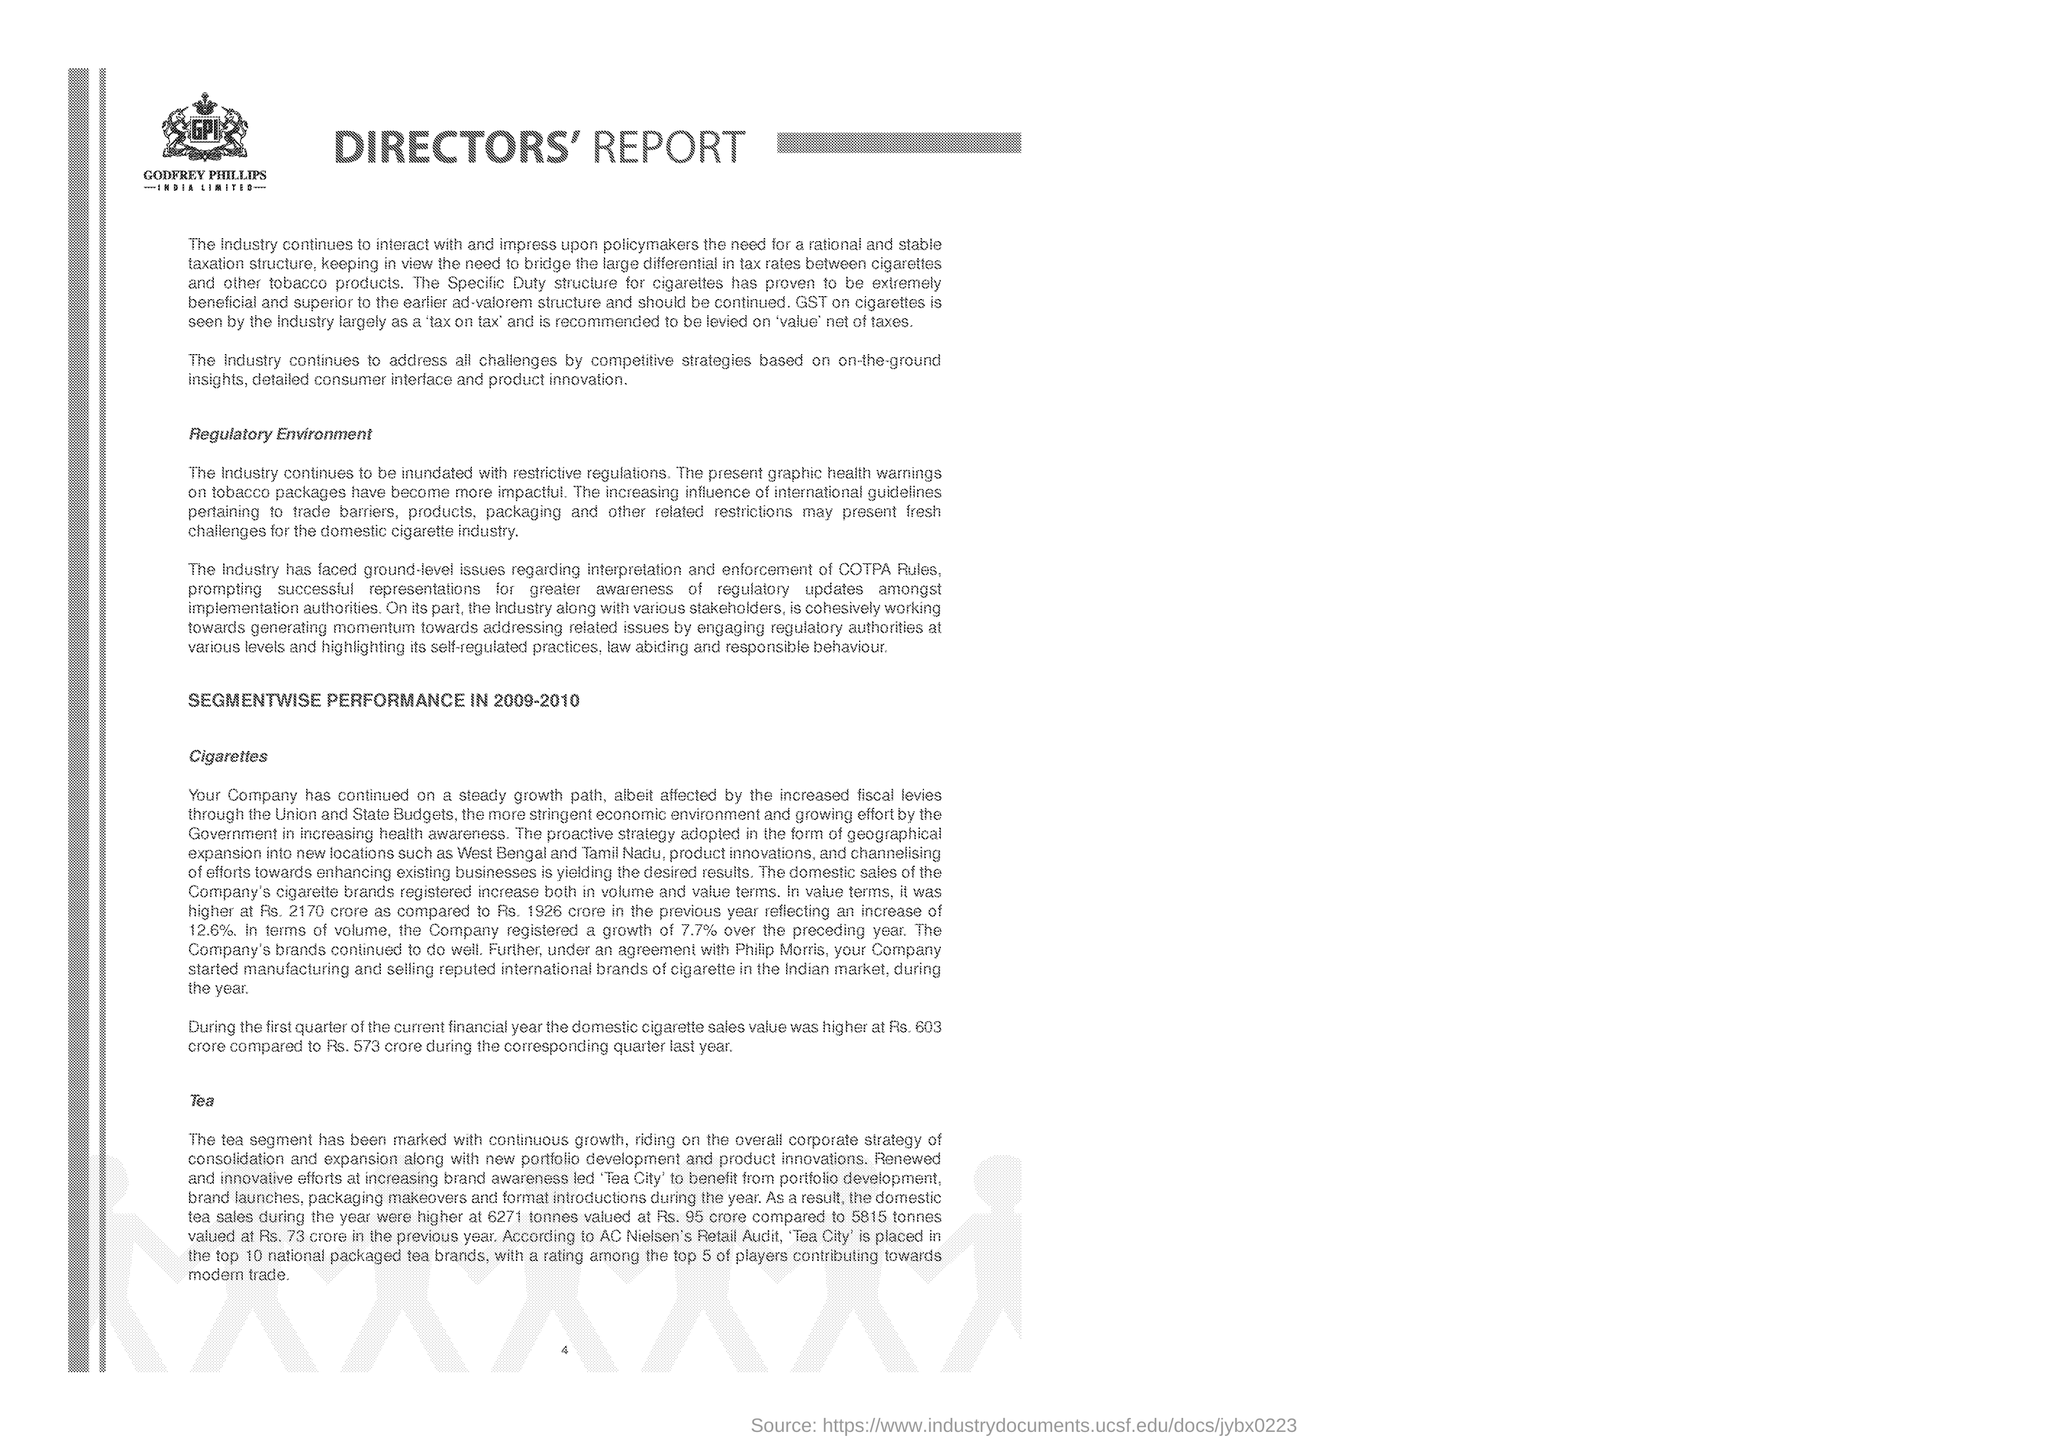What is written within the logo?
Offer a terse response. GPI. What is the heading of the document?
Ensure brevity in your answer.  DIRECTORS' REPORT. "GST on cigarettes is seen by the industry largely as" what?
Offer a terse response. 'tax on tax'. What is the first side heading given?
Your response must be concise. Regulatory Environment. What is the first item mentioned under "SEGMENTWISE PERFORMANCE IN 2009-2010" as subheading??
Offer a terse response. Cigarettes. "SEGMENTWISE PERFORMANCE IN" which year is mentioned?
Keep it short and to the point. 2009-2010. What percentage of increase was seen in "domestic sales of the Company's cigarette brands"?
Ensure brevity in your answer.  12.6%. In terms of volume, the company registered what percentage of growth over the preceeding year?
Offer a terse response. 7.7%. 'Tea City' is placed in the top 10 national packaged tea brands according to whose Retail Audit?
Provide a succinct answer. AC Nielsen's. 